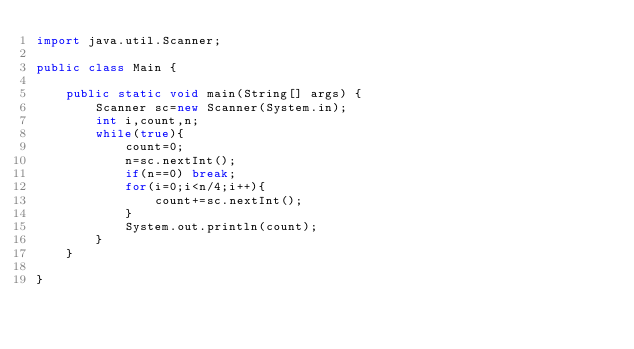Convert code to text. <code><loc_0><loc_0><loc_500><loc_500><_Java_>import java.util.Scanner;

public class Main {

	public static void main(String[] args) {
		Scanner sc=new Scanner(System.in);
		int i,count,n;
		while(true){
			count=0;
			n=sc.nextInt();
			if(n==0) break;
			for(i=0;i<n/4;i++){
				count+=sc.nextInt();
			}
			System.out.println(count);
		}
	}

}</code> 